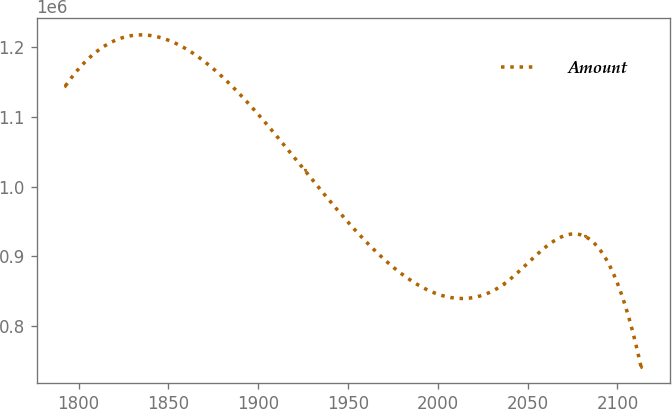Convert chart. <chart><loc_0><loc_0><loc_500><loc_500><line_chart><ecel><fcel>Amount<nl><fcel>1792.63<fcel>1.14457e+06<nl><fcel>1925.82<fcel>1.02353e+06<nl><fcel>2037.07<fcel>860292<nl><fcel>2081.85<fcel>928360<nl><fcel>2113.12<fcel>741169<nl></chart> 